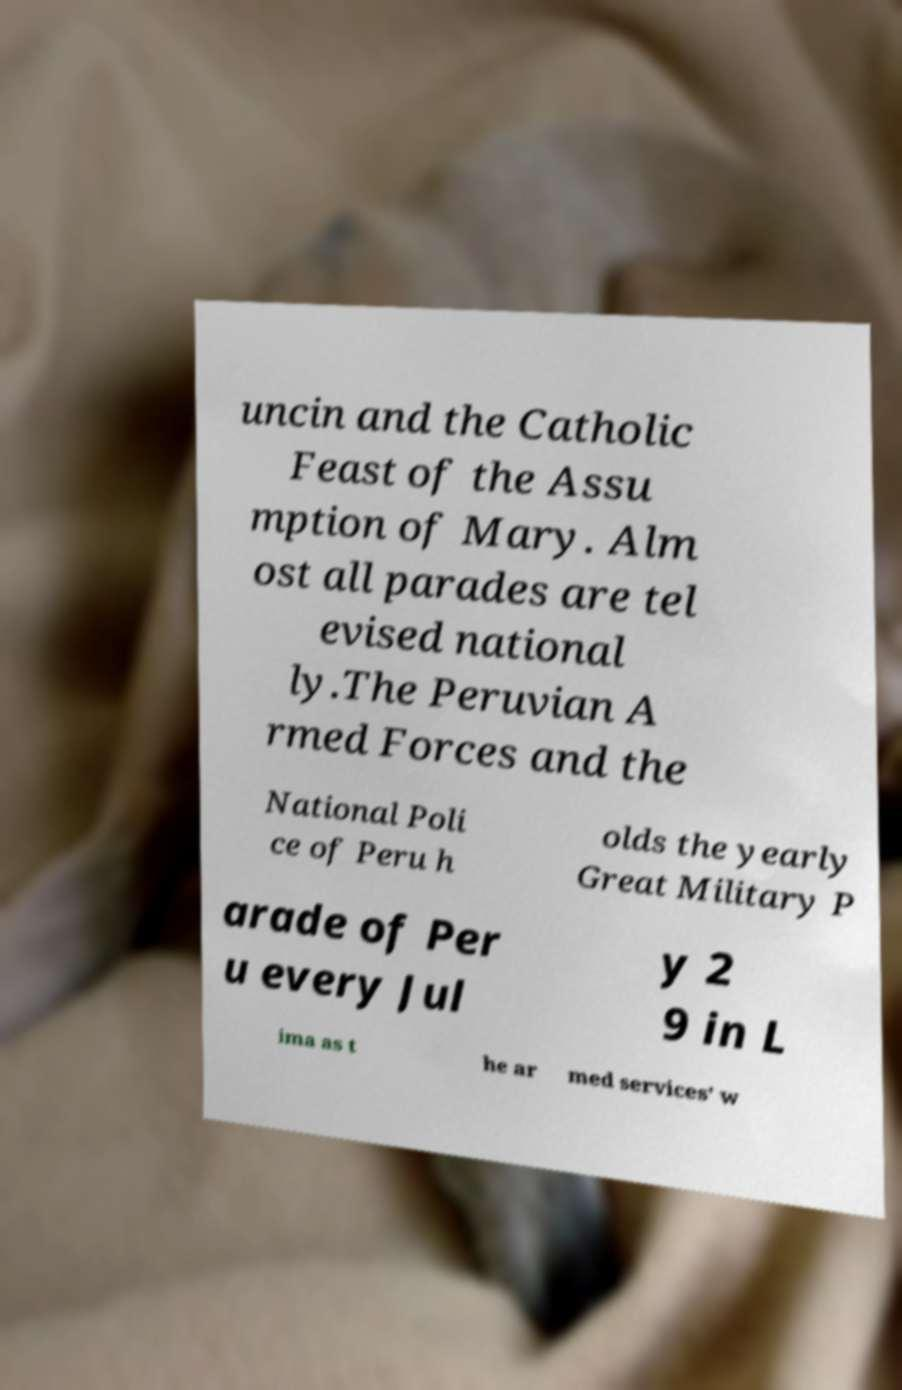Could you assist in decoding the text presented in this image and type it out clearly? uncin and the Catholic Feast of the Assu mption of Mary. Alm ost all parades are tel evised national ly.The Peruvian A rmed Forces and the National Poli ce of Peru h olds the yearly Great Military P arade of Per u every Jul y 2 9 in L ima as t he ar med services' w 